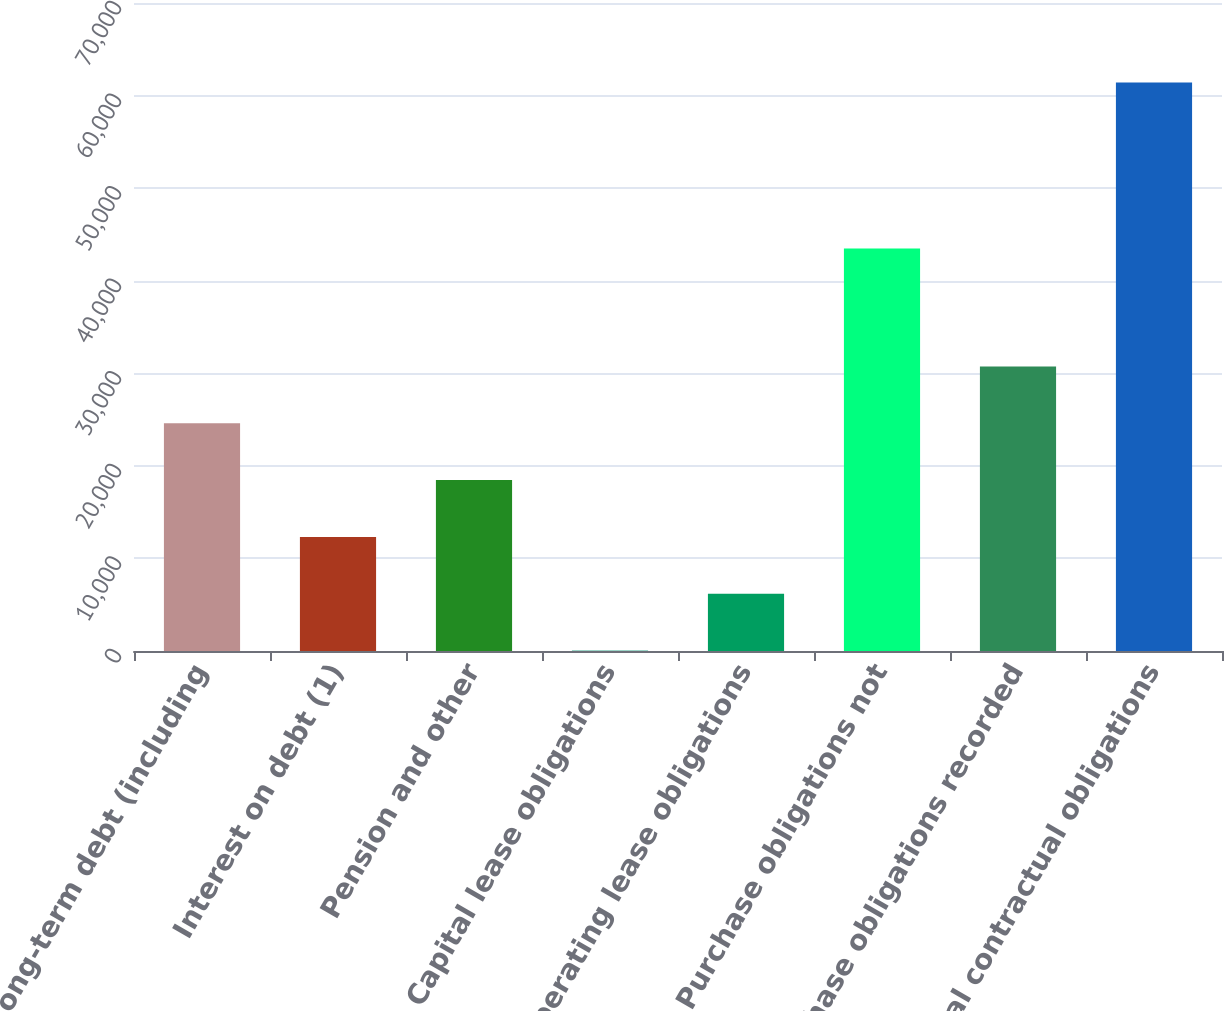Convert chart. <chart><loc_0><loc_0><loc_500><loc_500><bar_chart><fcel>Long-term debt (including<fcel>Interest on debt (1)<fcel>Pension and other<fcel>Capital lease obligations<fcel>Operating lease obligations<fcel>Purchase obligations not<fcel>Purchase obligations recorded<fcel>Total contractual obligations<nl><fcel>24598.2<fcel>12326.6<fcel>18462.4<fcel>55<fcel>6190.8<fcel>43471<fcel>30734<fcel>61413<nl></chart> 